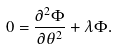Convert formula to latex. <formula><loc_0><loc_0><loc_500><loc_500>0 = \frac { \partial ^ { 2 } \Phi } { \partial \theta ^ { 2 } } + \lambda \Phi .</formula> 